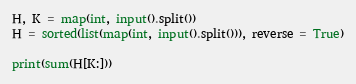Convert code to text. <code><loc_0><loc_0><loc_500><loc_500><_Python_>H, K = map(int, input().split())
H = sorted(list(map(int, input().split())), reverse = True)

print(sum(H[K:]))</code> 